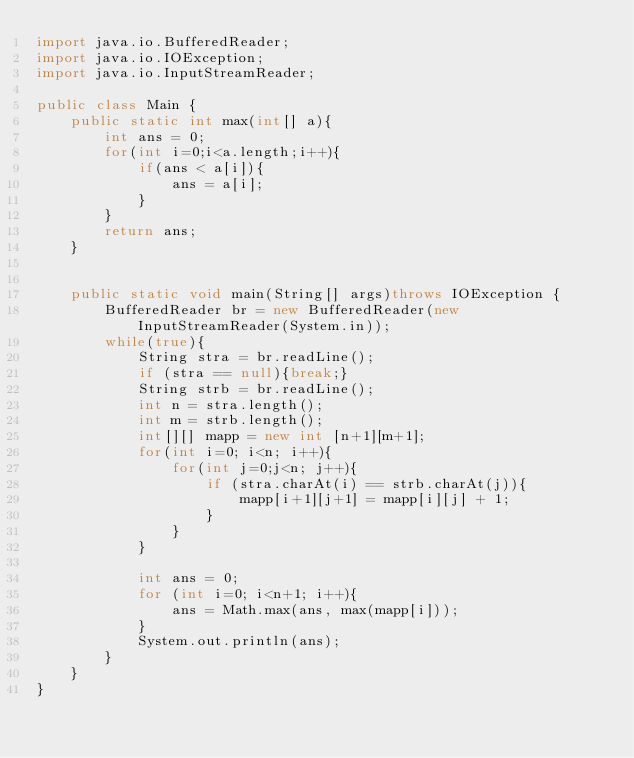<code> <loc_0><loc_0><loc_500><loc_500><_Java_>import java.io.BufferedReader;
import java.io.IOException;
import java.io.InputStreamReader;

public class Main {
	public static int max(int[] a){
		int ans = 0;
		for(int i=0;i<a.length;i++){
			if(ans < a[i]){
				ans = a[i];
			}
		}
		return ans;
	}


	public static void main(String[] args)throws IOException {
		BufferedReader br = new BufferedReader(new InputStreamReader(System.in));
		while(true){
			String stra = br.readLine();
			if (stra == null){break;}
			String strb = br.readLine();
			int n = stra.length();
			int m = strb.length();
			int[][] mapp = new int [n+1][m+1];
			for(int i=0; i<n; i++){
				for(int j=0;j<n; j++){
					if (stra.charAt(i) == strb.charAt(j)){
						mapp[i+1][j+1] = mapp[i][j] + 1;
					}
				}
			}

			int ans = 0;
			for (int i=0; i<n+1; i++){
				ans = Math.max(ans, max(mapp[i]));
			}
			System.out.println(ans);
		}
	}
}</code> 